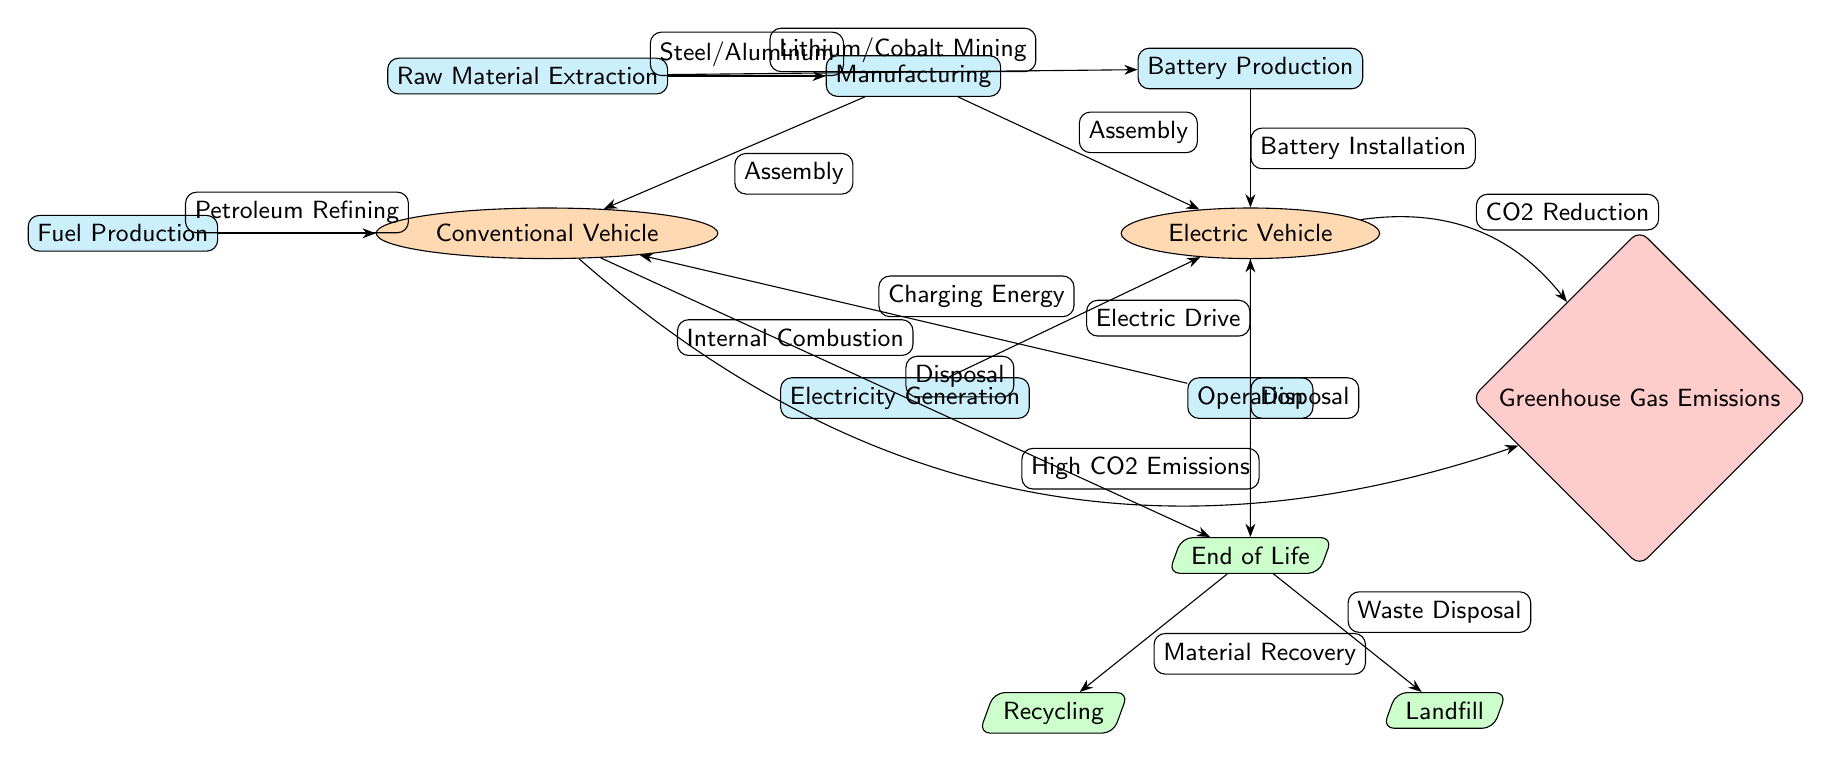What are the two types of vehicles mentioned in the diagram? The diagram identifies two vehicle types: Electric Vehicle and Conventional Vehicle. These are represented as distinct nodes connected to the Manufacturing node.
Answer: Electric Vehicle, Conventional Vehicle What is the process for producing electricity for the Electric Vehicle? The Electric Vehicle node is connected to the Electricity Generation process node via the Charging Energy edge. This indicates that electricity generation is necessary for EV operation.
Answer: Electricity Generation How many end-of-life disposal methods are depicted in the diagram? The End of Life node branches into two disposal methods: Recycling and Landfill, which indicates a total of two methods shown in the diagram.
Answer: 2 Which vehicle type is associated with high CO2 emissions? The diagram shows an edge labeled "High CO2 Emissions" connecting the Conventional Vehicle to the Greenhouse Gas Emissions node, indicating that the Conventional Vehicle is linked to high emissions.
Answer: Conventional Vehicle What is the relationship between battery production and the Electric Vehicle? The Battery Production process node has a direct edge labeled "Battery Installation" connecting it to the Electric Vehicle node, indicating that the battery production is essential for Electric Vehicle assembly.
Answer: Battery Installation What happens to materials at the end-of-life for both vehicle types? The End of Life node connects to two outcomes: Material Recovery leading to Recycling and Waste Disposal leading to Landfill. This means materials are either recycled or sent to landfill after disposal.
Answer: Recycling, Landfill Is there any process that specifically relates to fuel production? Yes, there is a process node labeled Fuel Production that directly connects to the Conventional Vehicle, showing that fuel production is specifically tied to this vehicle type.
Answer: Fuel Production Which vehicle type has a process named "Electric Drive"? The Electric Drive process is connected directly to the Electric Vehicle node, indicating that this is a specific operation associated with Electric Vehicles.
Answer: Electric Vehicle 